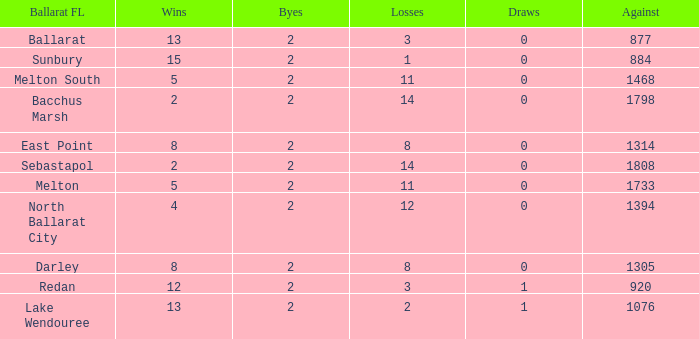How many Byes have Against of 1076 and Wins smaller than 13? None. 